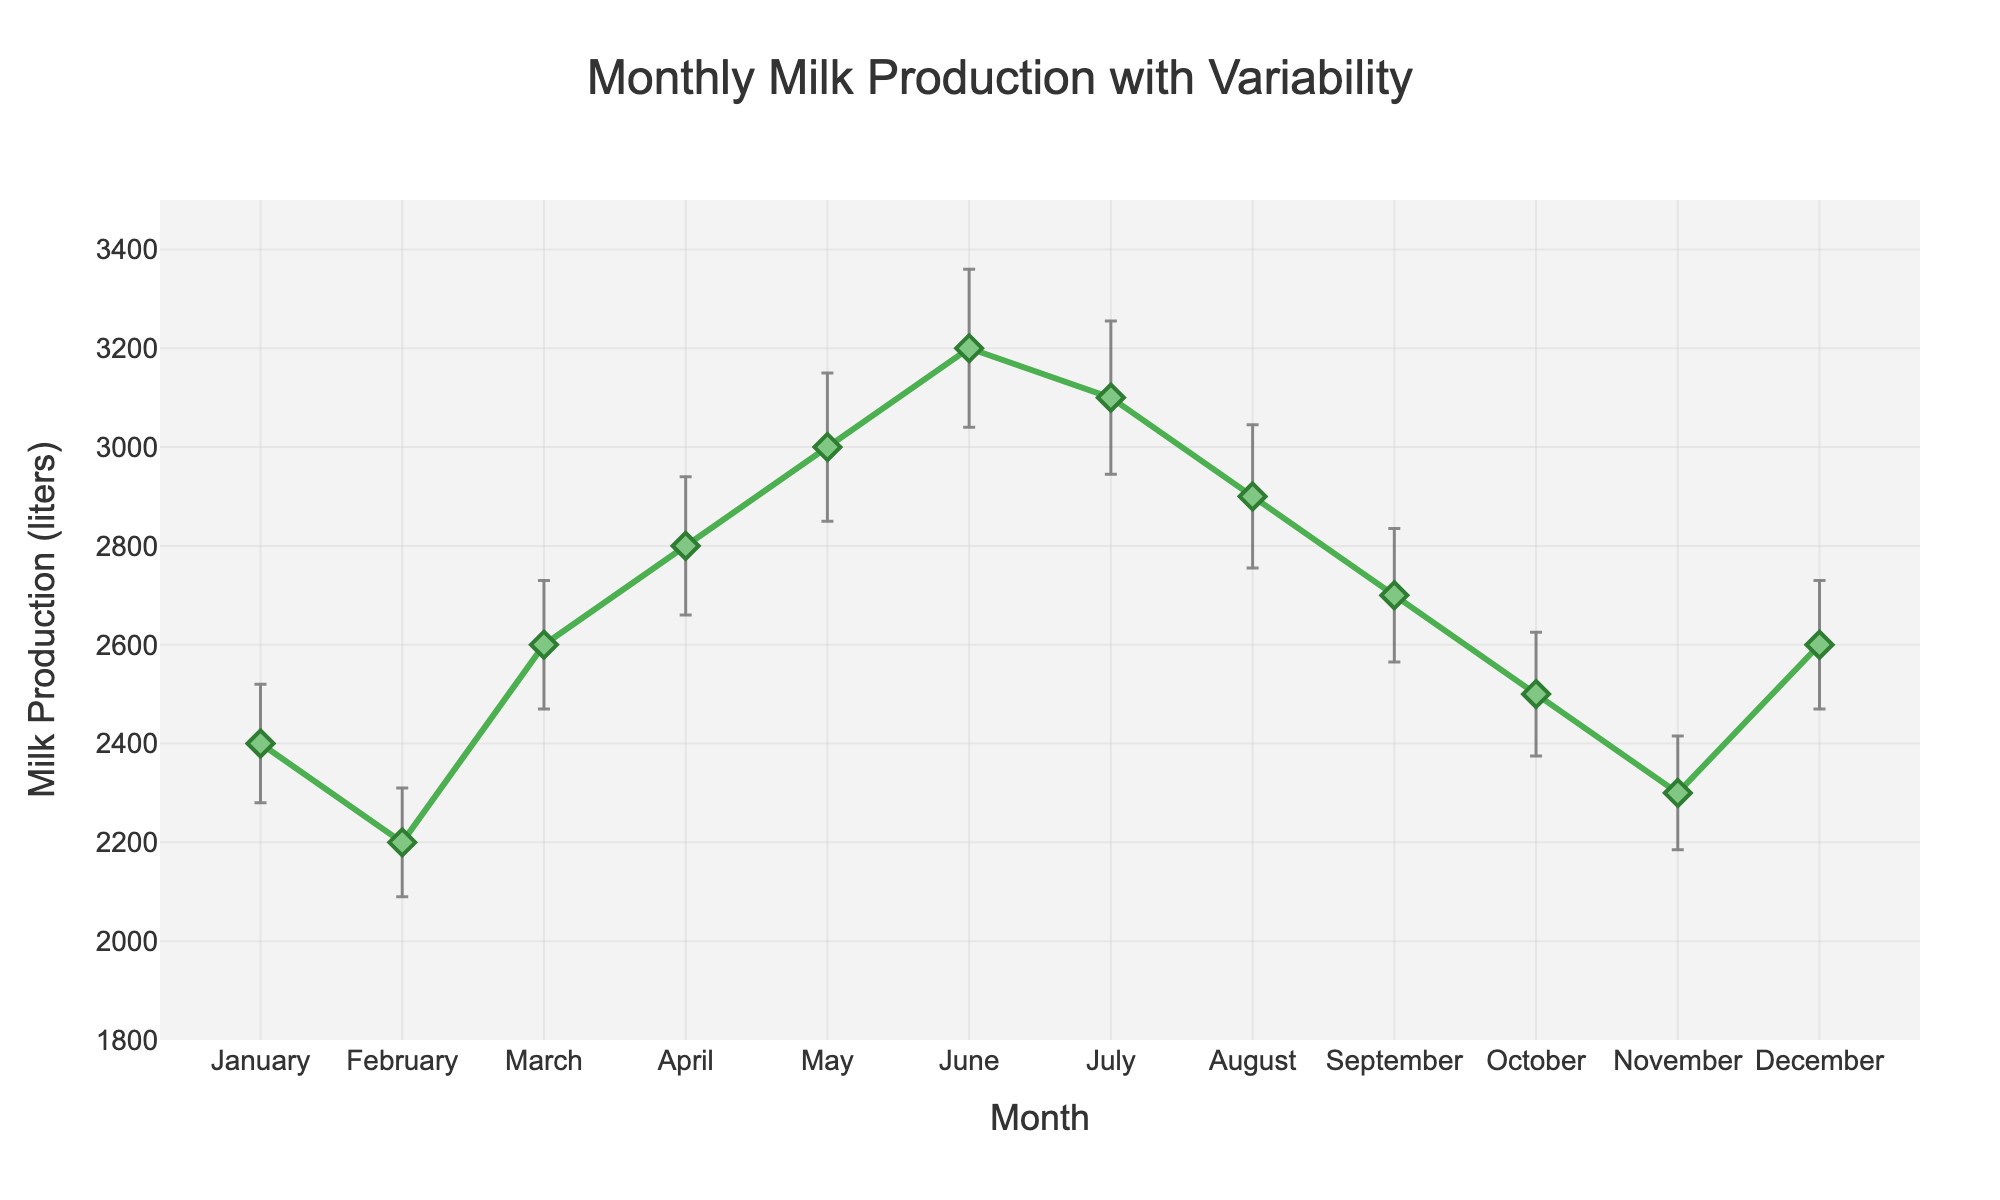What's the title of the figure? The title of the figure is displayed at the top and gives an overview of what the plot represents. It reads "Monthly Milk Production with Variability."
Answer: Monthly Milk Production with Variability What is the average milk production in June? To find the average milk production in June, locate June on the x-axis and see the corresponding y-value. The plot shows an average of 3200 liters in June.
Answer: 3200 liters Which month has the highest average milk production? To find the month with the highest average milk production, examine the y-values of all points and find the maximum. May has the highest average with 3000 liters.
Answer: May What is the standard deviation in September? The standard deviation can be identified by looking at the error bars associated with the September data point. The plot shows a standard deviation of 135 liters in September.
Answer: 135 liters How does the milk production in March compare to November? Locate March and November on the x-axis and compare their y-values. March has an average production of 2600 liters, whereas November has 2300 liters. March's production is higher.
Answer: March is higher What is the range of standard deviations throughout the year? To find the range, identify the smallest and largest standard deviations throughout the year. The minimum is 110 liters (February), and the maximum is 160 liters (June). The range is 160 - 110 = 50.
Answer: 50 liters What months have milk production close to 2600 liters on average? Look for months where the y-values are close to 2600 liters. Both March and December have averages of 2600 liters.
Answer: March and December Which month shows the greatest variability in milk production? The month with the largest error bar indicates the greatest variability. June has the largest error bar with a standard deviation of 160 liters.
Answer: June How does the average milk production in January compare to December? To compare January and December, look at their average values. January's average is 2400 liters, and December is 2600 liters. December has 200 liters more.
Answer: December is higher What is the total average milk production from January to March? Sum the averages from January to March: 2400 (January) + 2200 (February) + 2600 (March) = 7200 liters.
Answer: 7200 liters 